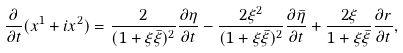<formula> <loc_0><loc_0><loc_500><loc_500>\frac { \partial } { \partial t } ( x ^ { 1 } + i x ^ { 2 } ) = \frac { 2 } { ( 1 + \xi \bar { \xi } ) ^ { 2 } } \frac { \partial \eta } { \partial t } - \frac { 2 \xi ^ { 2 } } { ( 1 + \xi \bar { \xi } ) ^ { 2 } } \frac { \partial \bar { \eta } } { \partial t } + \frac { 2 \xi } { 1 + \xi \bar { \xi } } \frac { \partial r } { \partial t } ,</formula> 